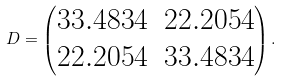<formula> <loc_0><loc_0><loc_500><loc_500>D = \begin{pmatrix} 3 3 . 4 8 3 4 & 2 2 . 2 0 5 4 \\ 2 2 . 2 0 5 4 & 3 3 . 4 8 3 4 \\ \end{pmatrix} .</formula> 